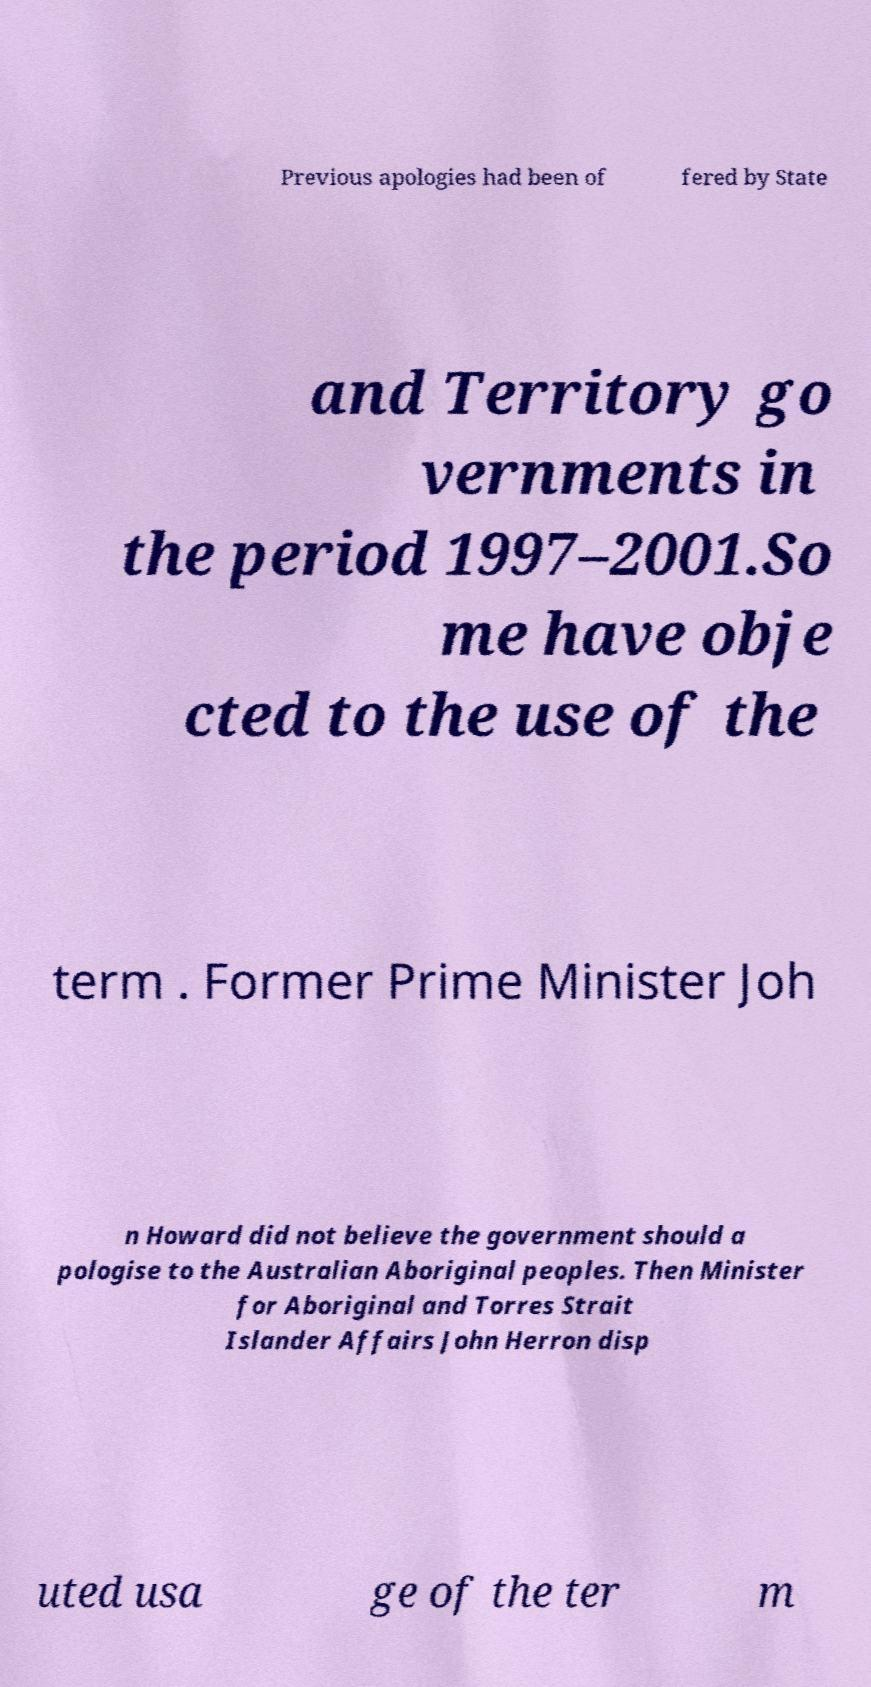What messages or text are displayed in this image? I need them in a readable, typed format. Previous apologies had been of fered by State and Territory go vernments in the period 1997–2001.So me have obje cted to the use of the term . Former Prime Minister Joh n Howard did not believe the government should a pologise to the Australian Aboriginal peoples. Then Minister for Aboriginal and Torres Strait Islander Affairs John Herron disp uted usa ge of the ter m 